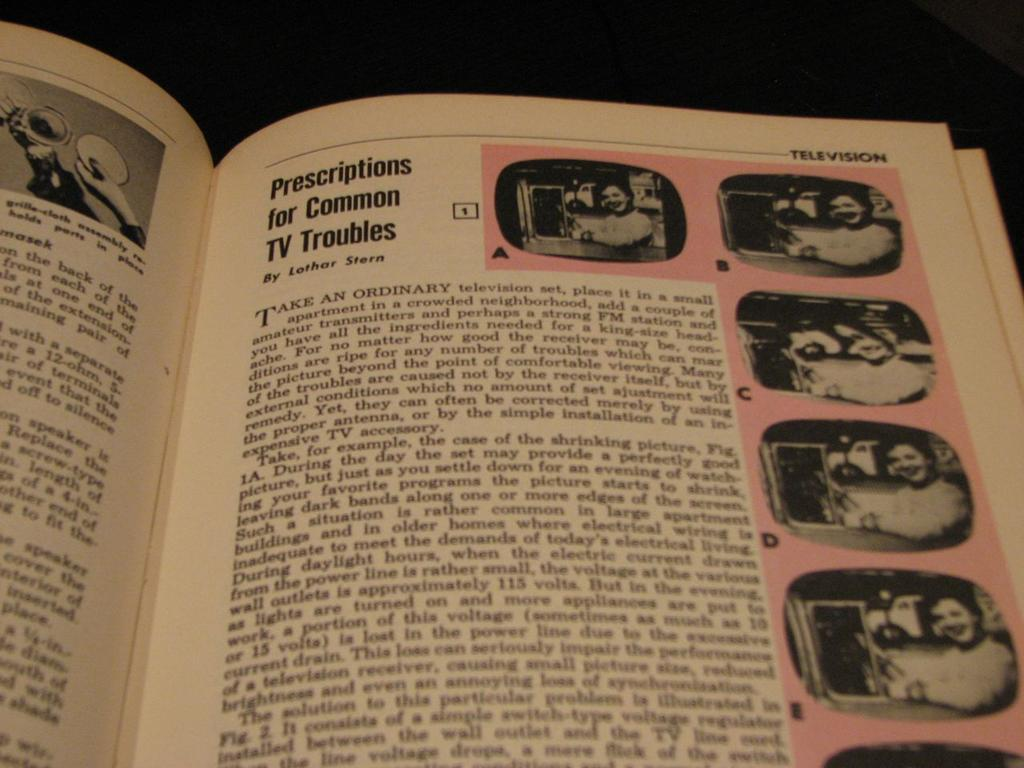<image>
Render a clear and concise summary of the photo. A book is open to an article by Lothar Stern about television. 